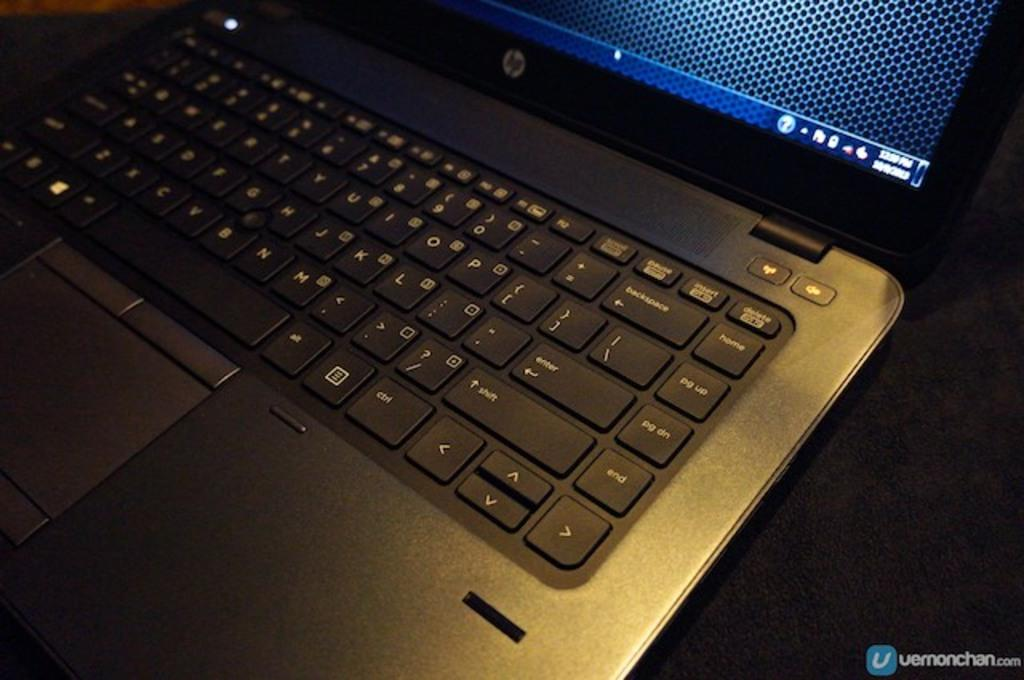<image>
Present a compact description of the photo's key features. the word end is on a key on a laptop 